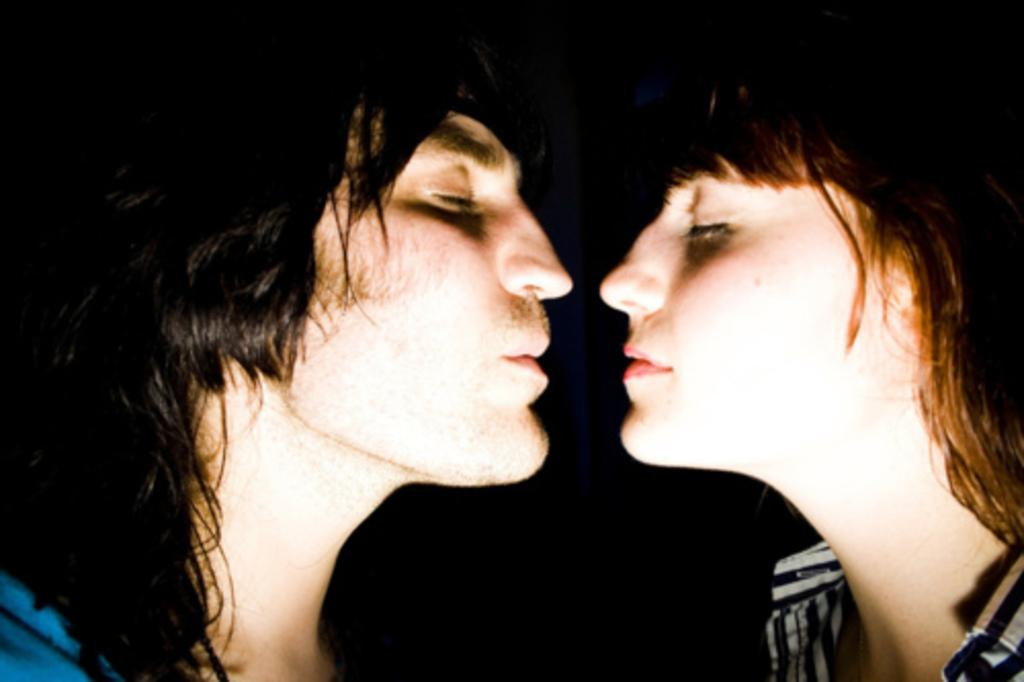How many people are in the image? There are two persons in the image. What are the persons wearing? Both persons are wearing dresses. What type of guitar is the person on the left playing in the image? There is no guitar present in the image; both persons are wearing dresses. Can you see a ring on the finger of the person on the right in the image? There is no ring visible on the finger of the person on the right in the image. 